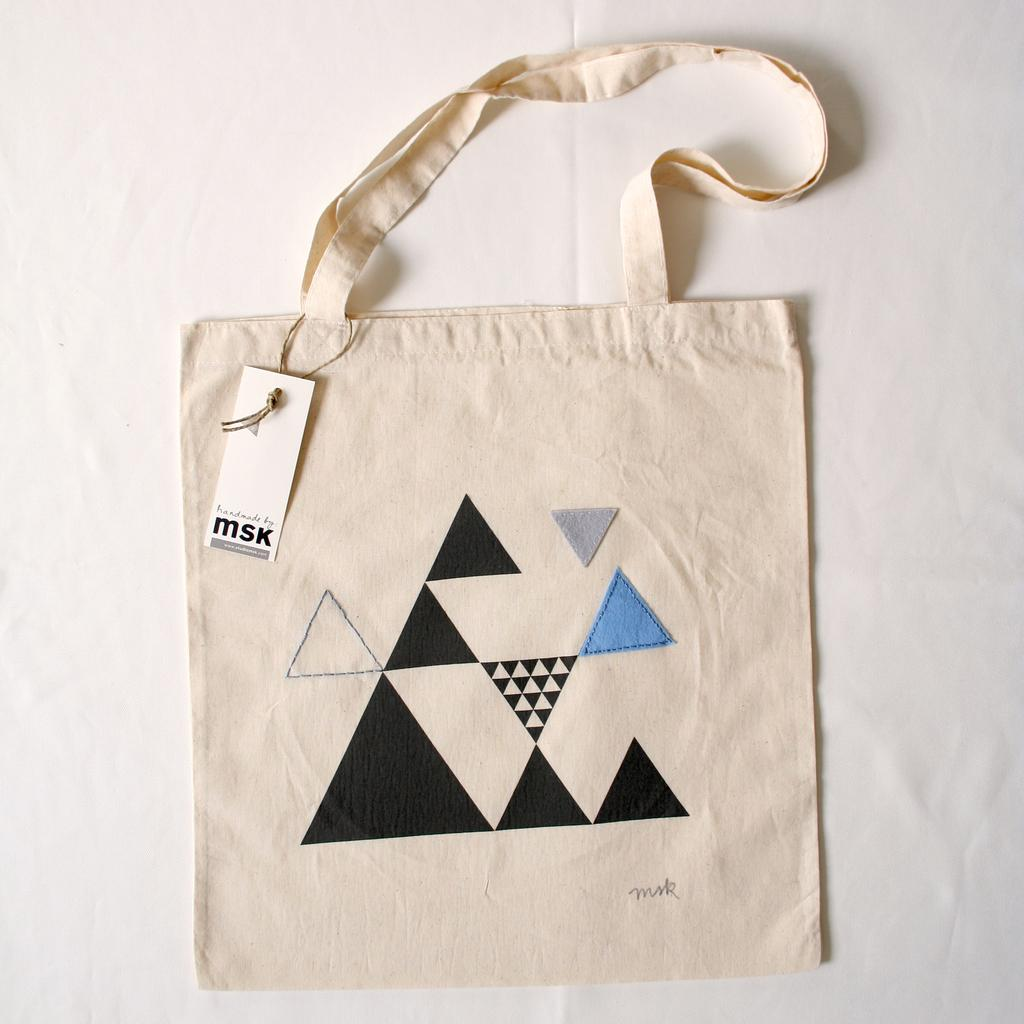What object is present in the image? There is a bag in the image. Can you describe the color of the bag? The bag is cream-colored. Is there any additional information on the bag? Yes, the bag has a tag with "MSK" written on it. What design can be seen on the bag? There is a design on the bag that resembles a triangle. How many pancakes are being held by the hands in the image? There are no pancakes or hands present in the image; it only features a bag with a tag and a triangle design. 